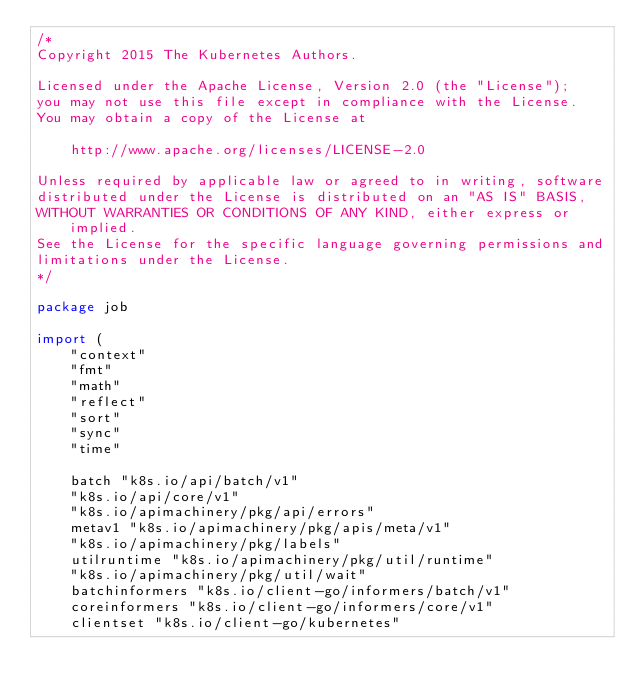<code> <loc_0><loc_0><loc_500><loc_500><_Go_>/*
Copyright 2015 The Kubernetes Authors.

Licensed under the Apache License, Version 2.0 (the "License");
you may not use this file except in compliance with the License.
You may obtain a copy of the License at

    http://www.apache.org/licenses/LICENSE-2.0

Unless required by applicable law or agreed to in writing, software
distributed under the License is distributed on an "AS IS" BASIS,
WITHOUT WARRANTIES OR CONDITIONS OF ANY KIND, either express or implied.
See the License for the specific language governing permissions and
limitations under the License.
*/

package job

import (
	"context"
	"fmt"
	"math"
	"reflect"
	"sort"
	"sync"
	"time"

	batch "k8s.io/api/batch/v1"
	"k8s.io/api/core/v1"
	"k8s.io/apimachinery/pkg/api/errors"
	metav1 "k8s.io/apimachinery/pkg/apis/meta/v1"
	"k8s.io/apimachinery/pkg/labels"
	utilruntime "k8s.io/apimachinery/pkg/util/runtime"
	"k8s.io/apimachinery/pkg/util/wait"
	batchinformers "k8s.io/client-go/informers/batch/v1"
	coreinformers "k8s.io/client-go/informers/core/v1"
	clientset "k8s.io/client-go/kubernetes"</code> 